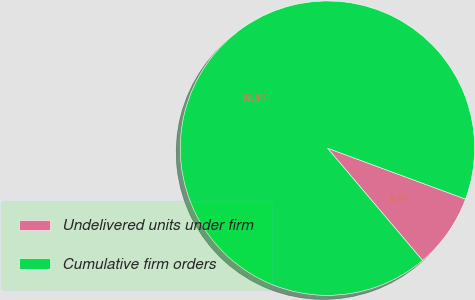Convert chart. <chart><loc_0><loc_0><loc_500><loc_500><pie_chart><fcel>Undelivered units under firm<fcel>Cumulative firm orders<nl><fcel>8.19%<fcel>91.81%<nl></chart> 